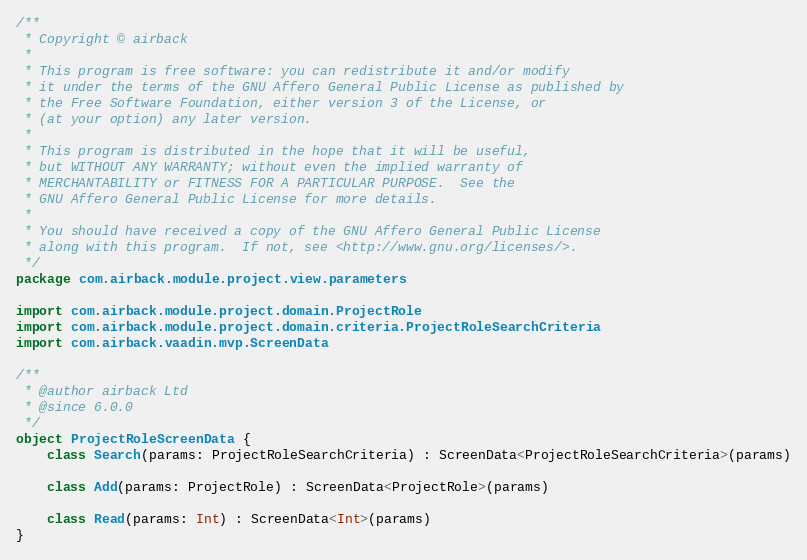<code> <loc_0><loc_0><loc_500><loc_500><_Kotlin_>/**
 * Copyright © airback
 *
 * This program is free software: you can redistribute it and/or modify
 * it under the terms of the GNU Affero General Public License as published by
 * the Free Software Foundation, either version 3 of the License, or
 * (at your option) any later version.
 *
 * This program is distributed in the hope that it will be useful,
 * but WITHOUT ANY WARRANTY; without even the implied warranty of
 * MERCHANTABILITY or FITNESS FOR A PARTICULAR PURPOSE.  See the
 * GNU Affero General Public License for more details.
 *
 * You should have received a copy of the GNU Affero General Public License
 * along with this program.  If not, see <http://www.gnu.org/licenses/>.
 */
package com.airback.module.project.view.parameters

import com.airback.module.project.domain.ProjectRole
import com.airback.module.project.domain.criteria.ProjectRoleSearchCriteria
import com.airback.vaadin.mvp.ScreenData

/**
 * @author airback Ltd
 * @since 6.0.0
 */
object ProjectRoleScreenData {
    class Search(params: ProjectRoleSearchCriteria) : ScreenData<ProjectRoleSearchCriteria>(params)

    class Add(params: ProjectRole) : ScreenData<ProjectRole>(params)

    class Read(params: Int) : ScreenData<Int>(params) 
}</code> 